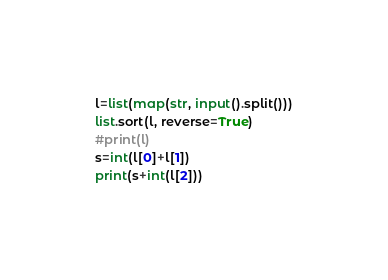<code> <loc_0><loc_0><loc_500><loc_500><_Python_>l=list(map(str, input().split()))
list.sort(l, reverse=True)
#print(l)
s=int(l[0]+l[1])
print(s+int(l[2]))
</code> 